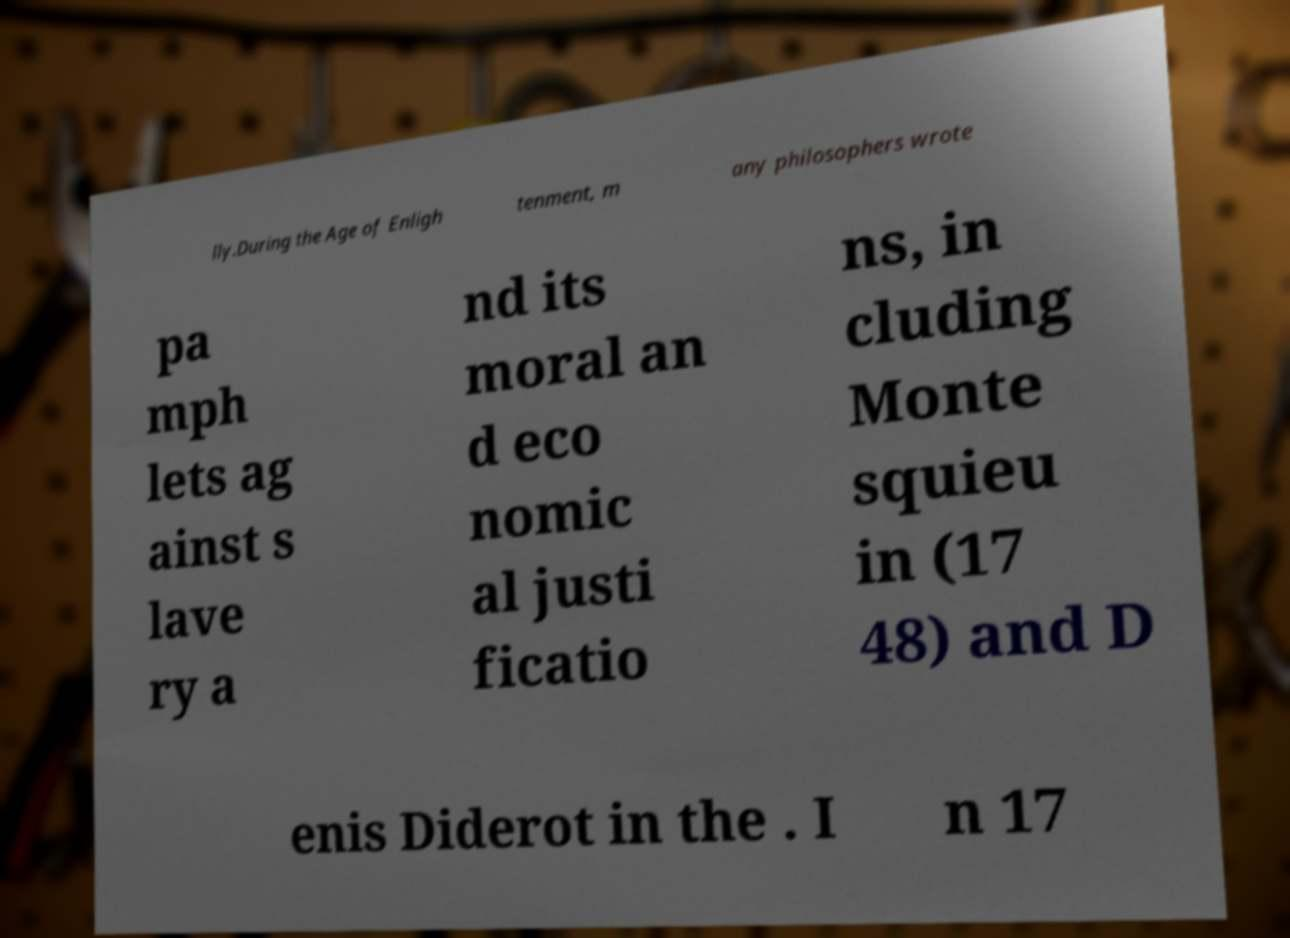Please identify and transcribe the text found in this image. lly.During the Age of Enligh tenment, m any philosophers wrote pa mph lets ag ainst s lave ry a nd its moral an d eco nomic al justi ficatio ns, in cluding Monte squieu in (17 48) and D enis Diderot in the . I n 17 